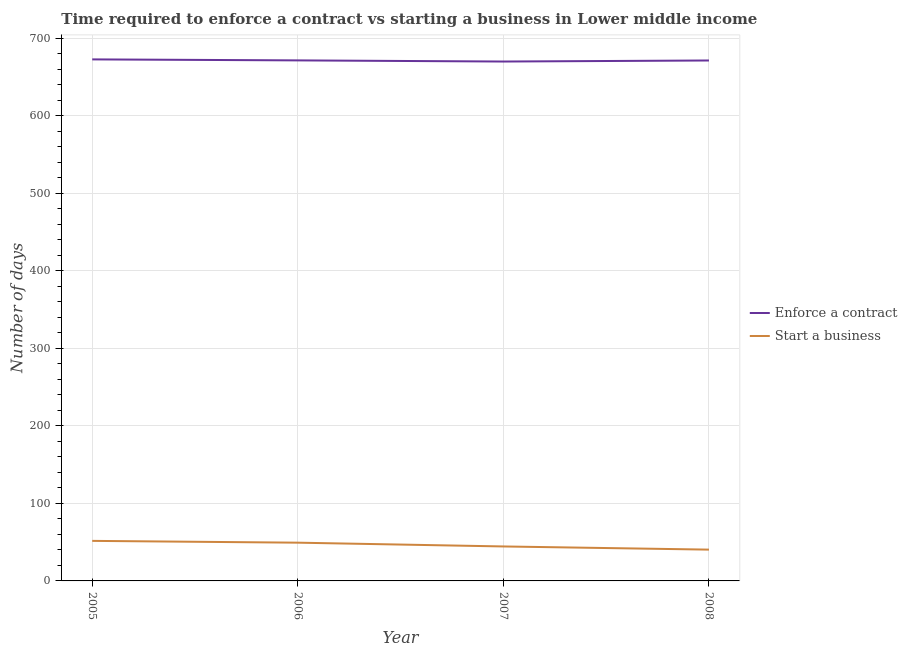What is the number of days to start a business in 2005?
Your answer should be very brief. 51.66. Across all years, what is the maximum number of days to start a business?
Your response must be concise. 51.66. Across all years, what is the minimum number of days to enforece a contract?
Ensure brevity in your answer.  670.11. In which year was the number of days to enforece a contract minimum?
Provide a succinct answer. 2007. What is the total number of days to start a business in the graph?
Keep it short and to the point. 185.84. What is the difference between the number of days to enforece a contract in 2005 and that in 2008?
Make the answer very short. 1.41. What is the difference between the number of days to enforece a contract in 2005 and the number of days to start a business in 2006?
Offer a terse response. 623.55. What is the average number of days to start a business per year?
Provide a short and direct response. 46.46. In the year 2007, what is the difference between the number of days to enforece a contract and number of days to start a business?
Make the answer very short. 625.65. What is the ratio of the number of days to start a business in 2007 to that in 2008?
Make the answer very short. 1.1. Is the number of days to start a business in 2005 less than that in 2007?
Offer a very short reply. No. Is the difference between the number of days to start a business in 2007 and 2008 greater than the difference between the number of days to enforece a contract in 2007 and 2008?
Offer a very short reply. Yes. What is the difference between the highest and the second highest number of days to enforece a contract?
Your response must be concise. 1.3. What is the difference between the highest and the lowest number of days to start a business?
Keep it short and to the point. 11.28. Does the number of days to start a business monotonically increase over the years?
Give a very brief answer. No. How many lines are there?
Ensure brevity in your answer.  2. Are the values on the major ticks of Y-axis written in scientific E-notation?
Your answer should be compact. No. Does the graph contain any zero values?
Offer a very short reply. No. How many legend labels are there?
Your response must be concise. 2. What is the title of the graph?
Ensure brevity in your answer.  Time required to enforce a contract vs starting a business in Lower middle income. What is the label or title of the Y-axis?
Provide a short and direct response. Number of days. What is the Number of days of Enforce a contract in 2005?
Offer a terse response. 672.89. What is the Number of days of Start a business in 2005?
Give a very brief answer. 51.66. What is the Number of days of Enforce a contract in 2006?
Give a very brief answer. 671.59. What is the Number of days in Start a business in 2006?
Your answer should be compact. 49.34. What is the Number of days of Enforce a contract in 2007?
Make the answer very short. 670.11. What is the Number of days of Start a business in 2007?
Offer a terse response. 44.47. What is the Number of days in Enforce a contract in 2008?
Your answer should be compact. 671.48. What is the Number of days in Start a business in 2008?
Give a very brief answer. 40.38. Across all years, what is the maximum Number of days of Enforce a contract?
Offer a terse response. 672.89. Across all years, what is the maximum Number of days of Start a business?
Give a very brief answer. 51.66. Across all years, what is the minimum Number of days of Enforce a contract?
Your answer should be very brief. 670.11. Across all years, what is the minimum Number of days in Start a business?
Ensure brevity in your answer.  40.38. What is the total Number of days in Enforce a contract in the graph?
Provide a short and direct response. 2686.07. What is the total Number of days of Start a business in the graph?
Ensure brevity in your answer.  185.84. What is the difference between the Number of days of Enforce a contract in 2005 and that in 2006?
Offer a terse response. 1.3. What is the difference between the Number of days in Start a business in 2005 and that in 2006?
Your response must be concise. 2.32. What is the difference between the Number of days of Enforce a contract in 2005 and that in 2007?
Ensure brevity in your answer.  2.77. What is the difference between the Number of days in Start a business in 2005 and that in 2007?
Offer a terse response. 7.19. What is the difference between the Number of days in Enforce a contract in 2005 and that in 2008?
Keep it short and to the point. 1.41. What is the difference between the Number of days of Start a business in 2005 and that in 2008?
Your answer should be compact. 11.28. What is the difference between the Number of days of Enforce a contract in 2006 and that in 2007?
Provide a succinct answer. 1.48. What is the difference between the Number of days in Start a business in 2006 and that in 2007?
Your answer should be very brief. 4.88. What is the difference between the Number of days in Enforce a contract in 2006 and that in 2008?
Provide a succinct answer. 0.11. What is the difference between the Number of days of Start a business in 2006 and that in 2008?
Your answer should be very brief. 8.97. What is the difference between the Number of days in Enforce a contract in 2007 and that in 2008?
Your answer should be very brief. -1.36. What is the difference between the Number of days of Start a business in 2007 and that in 2008?
Keep it short and to the point. 4.09. What is the difference between the Number of days of Enforce a contract in 2005 and the Number of days of Start a business in 2006?
Offer a terse response. 623.55. What is the difference between the Number of days of Enforce a contract in 2005 and the Number of days of Start a business in 2007?
Provide a succinct answer. 628.42. What is the difference between the Number of days of Enforce a contract in 2005 and the Number of days of Start a business in 2008?
Your response must be concise. 632.51. What is the difference between the Number of days in Enforce a contract in 2006 and the Number of days in Start a business in 2007?
Your answer should be very brief. 627.12. What is the difference between the Number of days in Enforce a contract in 2006 and the Number of days in Start a business in 2008?
Offer a very short reply. 631.22. What is the difference between the Number of days of Enforce a contract in 2007 and the Number of days of Start a business in 2008?
Provide a short and direct response. 629.74. What is the average Number of days of Enforce a contract per year?
Keep it short and to the point. 671.52. What is the average Number of days in Start a business per year?
Offer a terse response. 46.46. In the year 2005, what is the difference between the Number of days in Enforce a contract and Number of days in Start a business?
Make the answer very short. 621.23. In the year 2006, what is the difference between the Number of days of Enforce a contract and Number of days of Start a business?
Make the answer very short. 622.25. In the year 2007, what is the difference between the Number of days of Enforce a contract and Number of days of Start a business?
Ensure brevity in your answer.  625.65. In the year 2008, what is the difference between the Number of days in Enforce a contract and Number of days in Start a business?
Your answer should be compact. 631.1. What is the ratio of the Number of days of Start a business in 2005 to that in 2006?
Offer a very short reply. 1.05. What is the ratio of the Number of days of Enforce a contract in 2005 to that in 2007?
Provide a succinct answer. 1. What is the ratio of the Number of days in Start a business in 2005 to that in 2007?
Your answer should be very brief. 1.16. What is the ratio of the Number of days in Start a business in 2005 to that in 2008?
Offer a very short reply. 1.28. What is the ratio of the Number of days in Start a business in 2006 to that in 2007?
Provide a succinct answer. 1.11. What is the ratio of the Number of days in Start a business in 2006 to that in 2008?
Offer a terse response. 1.22. What is the ratio of the Number of days of Enforce a contract in 2007 to that in 2008?
Provide a short and direct response. 1. What is the ratio of the Number of days of Start a business in 2007 to that in 2008?
Provide a succinct answer. 1.1. What is the difference between the highest and the second highest Number of days in Enforce a contract?
Your response must be concise. 1.3. What is the difference between the highest and the second highest Number of days of Start a business?
Your answer should be very brief. 2.32. What is the difference between the highest and the lowest Number of days of Enforce a contract?
Your answer should be compact. 2.77. What is the difference between the highest and the lowest Number of days in Start a business?
Your answer should be compact. 11.28. 